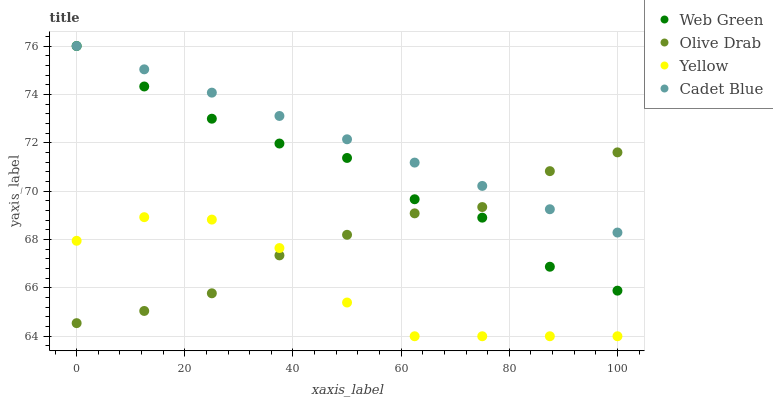Does Yellow have the minimum area under the curve?
Answer yes or no. Yes. Does Cadet Blue have the maximum area under the curve?
Answer yes or no. Yes. Does Olive Drab have the minimum area under the curve?
Answer yes or no. No. Does Olive Drab have the maximum area under the curve?
Answer yes or no. No. Is Cadet Blue the smoothest?
Answer yes or no. Yes. Is Yellow the roughest?
Answer yes or no. Yes. Is Olive Drab the smoothest?
Answer yes or no. No. Is Olive Drab the roughest?
Answer yes or no. No. Does Yellow have the lowest value?
Answer yes or no. Yes. Does Olive Drab have the lowest value?
Answer yes or no. No. Does Web Green have the highest value?
Answer yes or no. Yes. Does Olive Drab have the highest value?
Answer yes or no. No. Is Yellow less than Cadet Blue?
Answer yes or no. Yes. Is Cadet Blue greater than Yellow?
Answer yes or no. Yes. Does Olive Drab intersect Web Green?
Answer yes or no. Yes. Is Olive Drab less than Web Green?
Answer yes or no. No. Is Olive Drab greater than Web Green?
Answer yes or no. No. Does Yellow intersect Cadet Blue?
Answer yes or no. No. 